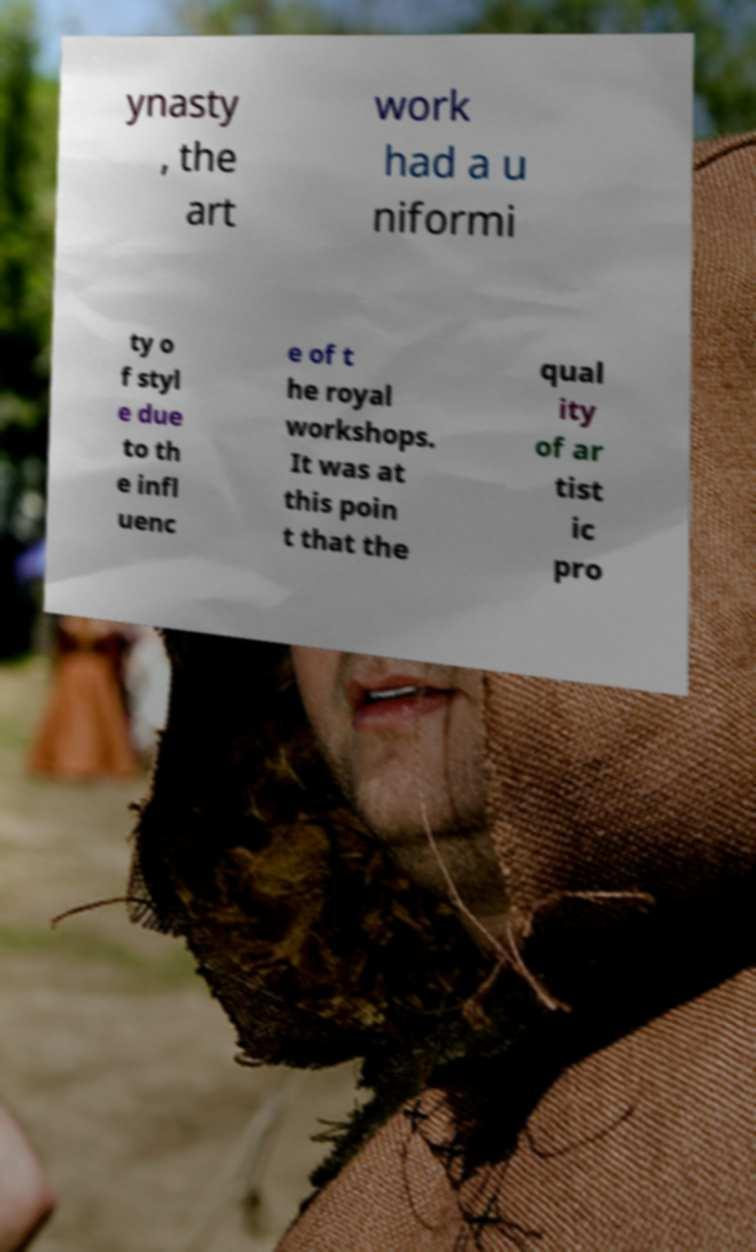There's text embedded in this image that I need extracted. Can you transcribe it verbatim? ynasty , the art work had a u niformi ty o f styl e due to th e infl uenc e of t he royal workshops. It was at this poin t that the qual ity of ar tist ic pro 